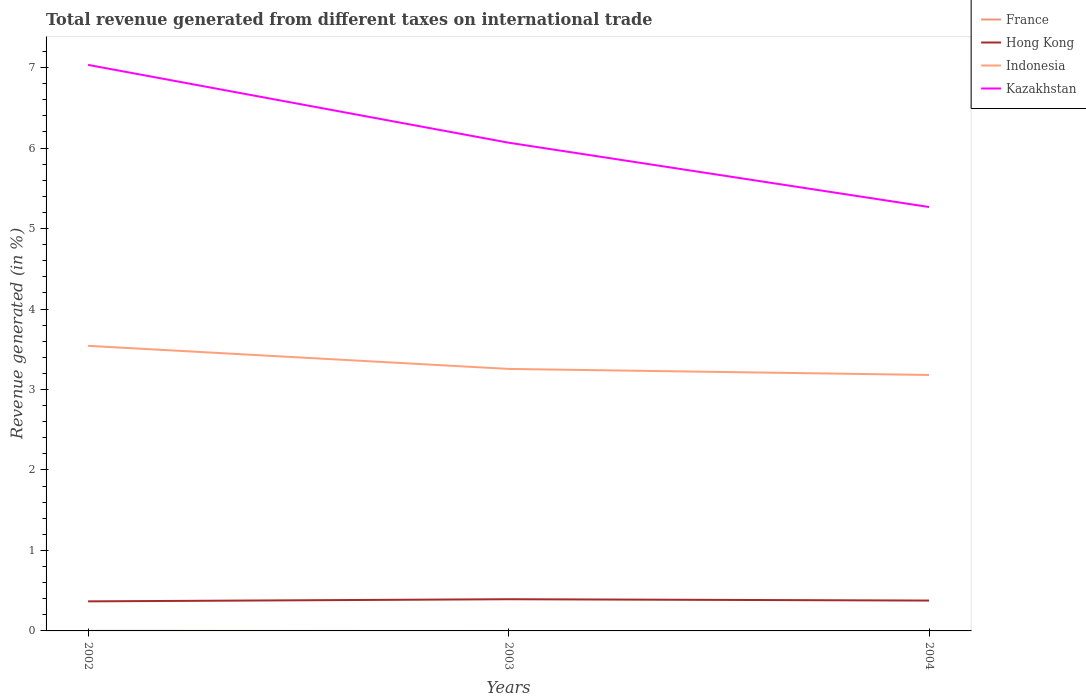How many different coloured lines are there?
Give a very brief answer. 4. Is the number of lines equal to the number of legend labels?
Provide a short and direct response. No. What is the total total revenue generated in Indonesia in the graph?
Your answer should be compact. 0.07. What is the difference between the highest and the second highest total revenue generated in Indonesia?
Provide a succinct answer. 0.36. What is the difference between the highest and the lowest total revenue generated in Hong Kong?
Provide a short and direct response. 1. How many years are there in the graph?
Keep it short and to the point. 3. Are the values on the major ticks of Y-axis written in scientific E-notation?
Your answer should be very brief. No. Does the graph contain any zero values?
Keep it short and to the point. Yes. Where does the legend appear in the graph?
Make the answer very short. Top right. How many legend labels are there?
Your response must be concise. 4. How are the legend labels stacked?
Give a very brief answer. Vertical. What is the title of the graph?
Your answer should be very brief. Total revenue generated from different taxes on international trade. Does "Cameroon" appear as one of the legend labels in the graph?
Give a very brief answer. No. What is the label or title of the X-axis?
Offer a very short reply. Years. What is the label or title of the Y-axis?
Your answer should be compact. Revenue generated (in %). What is the Revenue generated (in %) of France in 2002?
Your response must be concise. 0. What is the Revenue generated (in %) of Hong Kong in 2002?
Give a very brief answer. 0.37. What is the Revenue generated (in %) of Indonesia in 2002?
Your answer should be very brief. 3.54. What is the Revenue generated (in %) of Kazakhstan in 2002?
Ensure brevity in your answer.  7.03. What is the Revenue generated (in %) of Hong Kong in 2003?
Provide a short and direct response. 0.39. What is the Revenue generated (in %) in Indonesia in 2003?
Provide a short and direct response. 3.26. What is the Revenue generated (in %) in Kazakhstan in 2003?
Offer a terse response. 6.07. What is the Revenue generated (in %) in France in 2004?
Your response must be concise. 0. What is the Revenue generated (in %) in Hong Kong in 2004?
Offer a terse response. 0.38. What is the Revenue generated (in %) of Indonesia in 2004?
Give a very brief answer. 3.18. What is the Revenue generated (in %) of Kazakhstan in 2004?
Your response must be concise. 5.27. Across all years, what is the maximum Revenue generated (in %) in France?
Offer a very short reply. 0. Across all years, what is the maximum Revenue generated (in %) in Hong Kong?
Offer a terse response. 0.39. Across all years, what is the maximum Revenue generated (in %) in Indonesia?
Provide a short and direct response. 3.54. Across all years, what is the maximum Revenue generated (in %) of Kazakhstan?
Make the answer very short. 7.03. Across all years, what is the minimum Revenue generated (in %) in France?
Keep it short and to the point. 0. Across all years, what is the minimum Revenue generated (in %) in Hong Kong?
Provide a succinct answer. 0.37. Across all years, what is the minimum Revenue generated (in %) in Indonesia?
Keep it short and to the point. 3.18. Across all years, what is the minimum Revenue generated (in %) of Kazakhstan?
Provide a succinct answer. 5.27. What is the total Revenue generated (in %) of France in the graph?
Provide a short and direct response. 0. What is the total Revenue generated (in %) of Hong Kong in the graph?
Make the answer very short. 1.14. What is the total Revenue generated (in %) of Indonesia in the graph?
Ensure brevity in your answer.  9.98. What is the total Revenue generated (in %) of Kazakhstan in the graph?
Ensure brevity in your answer.  18.37. What is the difference between the Revenue generated (in %) in Hong Kong in 2002 and that in 2003?
Provide a short and direct response. -0.03. What is the difference between the Revenue generated (in %) in Indonesia in 2002 and that in 2003?
Your answer should be very brief. 0.29. What is the difference between the Revenue generated (in %) of Kazakhstan in 2002 and that in 2003?
Offer a terse response. 0.97. What is the difference between the Revenue generated (in %) in Hong Kong in 2002 and that in 2004?
Provide a short and direct response. -0.01. What is the difference between the Revenue generated (in %) in Indonesia in 2002 and that in 2004?
Your response must be concise. 0.36. What is the difference between the Revenue generated (in %) in Kazakhstan in 2002 and that in 2004?
Your answer should be very brief. 1.77. What is the difference between the Revenue generated (in %) of Hong Kong in 2003 and that in 2004?
Your response must be concise. 0.02. What is the difference between the Revenue generated (in %) of Indonesia in 2003 and that in 2004?
Ensure brevity in your answer.  0.07. What is the difference between the Revenue generated (in %) of Kazakhstan in 2003 and that in 2004?
Make the answer very short. 0.8. What is the difference between the Revenue generated (in %) of France in 2002 and the Revenue generated (in %) of Hong Kong in 2003?
Ensure brevity in your answer.  -0.39. What is the difference between the Revenue generated (in %) in France in 2002 and the Revenue generated (in %) in Indonesia in 2003?
Your response must be concise. -3.25. What is the difference between the Revenue generated (in %) of France in 2002 and the Revenue generated (in %) of Kazakhstan in 2003?
Provide a short and direct response. -6.07. What is the difference between the Revenue generated (in %) in Hong Kong in 2002 and the Revenue generated (in %) in Indonesia in 2003?
Your answer should be compact. -2.89. What is the difference between the Revenue generated (in %) of Hong Kong in 2002 and the Revenue generated (in %) of Kazakhstan in 2003?
Provide a succinct answer. -5.7. What is the difference between the Revenue generated (in %) in Indonesia in 2002 and the Revenue generated (in %) in Kazakhstan in 2003?
Offer a very short reply. -2.52. What is the difference between the Revenue generated (in %) in France in 2002 and the Revenue generated (in %) in Hong Kong in 2004?
Provide a succinct answer. -0.38. What is the difference between the Revenue generated (in %) of France in 2002 and the Revenue generated (in %) of Indonesia in 2004?
Offer a very short reply. -3.18. What is the difference between the Revenue generated (in %) of France in 2002 and the Revenue generated (in %) of Kazakhstan in 2004?
Ensure brevity in your answer.  -5.27. What is the difference between the Revenue generated (in %) of Hong Kong in 2002 and the Revenue generated (in %) of Indonesia in 2004?
Provide a short and direct response. -2.81. What is the difference between the Revenue generated (in %) in Hong Kong in 2002 and the Revenue generated (in %) in Kazakhstan in 2004?
Keep it short and to the point. -4.9. What is the difference between the Revenue generated (in %) in Indonesia in 2002 and the Revenue generated (in %) in Kazakhstan in 2004?
Offer a very short reply. -1.72. What is the difference between the Revenue generated (in %) in Hong Kong in 2003 and the Revenue generated (in %) in Indonesia in 2004?
Your answer should be compact. -2.79. What is the difference between the Revenue generated (in %) of Hong Kong in 2003 and the Revenue generated (in %) of Kazakhstan in 2004?
Give a very brief answer. -4.87. What is the difference between the Revenue generated (in %) of Indonesia in 2003 and the Revenue generated (in %) of Kazakhstan in 2004?
Keep it short and to the point. -2.01. What is the average Revenue generated (in %) in Hong Kong per year?
Offer a very short reply. 0.38. What is the average Revenue generated (in %) in Indonesia per year?
Your answer should be compact. 3.33. What is the average Revenue generated (in %) of Kazakhstan per year?
Provide a succinct answer. 6.12. In the year 2002, what is the difference between the Revenue generated (in %) of France and Revenue generated (in %) of Hong Kong?
Give a very brief answer. -0.37. In the year 2002, what is the difference between the Revenue generated (in %) in France and Revenue generated (in %) in Indonesia?
Your response must be concise. -3.54. In the year 2002, what is the difference between the Revenue generated (in %) in France and Revenue generated (in %) in Kazakhstan?
Give a very brief answer. -7.03. In the year 2002, what is the difference between the Revenue generated (in %) of Hong Kong and Revenue generated (in %) of Indonesia?
Your answer should be very brief. -3.18. In the year 2002, what is the difference between the Revenue generated (in %) of Hong Kong and Revenue generated (in %) of Kazakhstan?
Provide a short and direct response. -6.67. In the year 2002, what is the difference between the Revenue generated (in %) in Indonesia and Revenue generated (in %) in Kazakhstan?
Your answer should be compact. -3.49. In the year 2003, what is the difference between the Revenue generated (in %) of Hong Kong and Revenue generated (in %) of Indonesia?
Keep it short and to the point. -2.86. In the year 2003, what is the difference between the Revenue generated (in %) of Hong Kong and Revenue generated (in %) of Kazakhstan?
Provide a succinct answer. -5.67. In the year 2003, what is the difference between the Revenue generated (in %) in Indonesia and Revenue generated (in %) in Kazakhstan?
Keep it short and to the point. -2.81. In the year 2004, what is the difference between the Revenue generated (in %) of Hong Kong and Revenue generated (in %) of Indonesia?
Your answer should be very brief. -2.8. In the year 2004, what is the difference between the Revenue generated (in %) in Hong Kong and Revenue generated (in %) in Kazakhstan?
Provide a succinct answer. -4.89. In the year 2004, what is the difference between the Revenue generated (in %) in Indonesia and Revenue generated (in %) in Kazakhstan?
Your response must be concise. -2.09. What is the ratio of the Revenue generated (in %) of Hong Kong in 2002 to that in 2003?
Ensure brevity in your answer.  0.93. What is the ratio of the Revenue generated (in %) in Indonesia in 2002 to that in 2003?
Keep it short and to the point. 1.09. What is the ratio of the Revenue generated (in %) in Kazakhstan in 2002 to that in 2003?
Your response must be concise. 1.16. What is the ratio of the Revenue generated (in %) in Hong Kong in 2002 to that in 2004?
Ensure brevity in your answer.  0.97. What is the ratio of the Revenue generated (in %) of Indonesia in 2002 to that in 2004?
Give a very brief answer. 1.11. What is the ratio of the Revenue generated (in %) of Kazakhstan in 2002 to that in 2004?
Provide a short and direct response. 1.34. What is the ratio of the Revenue generated (in %) in Hong Kong in 2003 to that in 2004?
Provide a succinct answer. 1.04. What is the ratio of the Revenue generated (in %) in Indonesia in 2003 to that in 2004?
Ensure brevity in your answer.  1.02. What is the ratio of the Revenue generated (in %) of Kazakhstan in 2003 to that in 2004?
Provide a succinct answer. 1.15. What is the difference between the highest and the second highest Revenue generated (in %) of Hong Kong?
Offer a terse response. 0.02. What is the difference between the highest and the second highest Revenue generated (in %) in Indonesia?
Offer a terse response. 0.29. What is the difference between the highest and the second highest Revenue generated (in %) of Kazakhstan?
Provide a succinct answer. 0.97. What is the difference between the highest and the lowest Revenue generated (in %) of France?
Your answer should be very brief. 0. What is the difference between the highest and the lowest Revenue generated (in %) in Hong Kong?
Your answer should be compact. 0.03. What is the difference between the highest and the lowest Revenue generated (in %) in Indonesia?
Make the answer very short. 0.36. What is the difference between the highest and the lowest Revenue generated (in %) in Kazakhstan?
Offer a very short reply. 1.77. 